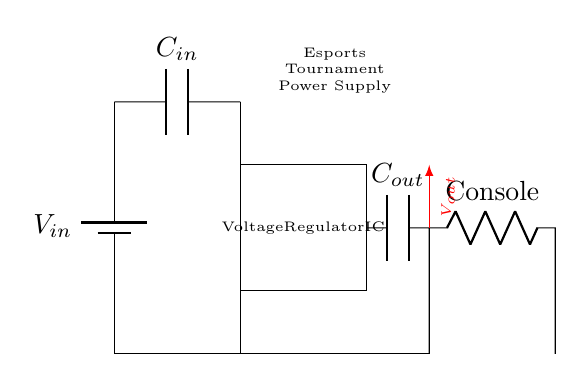What is the type of the power source in this circuit? The power source in the circuit is represented as a battery, indicated by the label "V_in". A battery is a common source of voltage in electronic circuits.
Answer: Battery What is the purpose of the capacitor labeled "C_out"? The capacitor "C_out" filters the output voltage, smoothing it to provide stable power to the connected load, which in this case is a gaming console.
Answer: Smoothing output Which component regulates the voltage in this circuit? The component that regulates the voltage is the Voltage Regulator IC, explicitly labeled in the diagram. This IC manages the output voltage level to maintain a consistent supply.
Answer: Voltage Regulator IC What is the load connected in this circuit? The load in this circuit is a console, as indicated by the label "Console". It draws the regulated voltage supplied by the circuit to operate during the tournament.
Answer: Console Which capacitor is responsible for input smoothing? The capacitor responsible for input smoothing is "C_in", which is connected to the input voltage source, filtering any fluctuations before they reach the regulator.
Answer: C_in How is the ground referenced in this circuit? The ground reference is indicated by the lines connecting to the bottom of the circuit, showing that several components return to a common ground point for a stable reference.
Answer: Common ground What role does the voltage labeled "V_out" play in the circuit? The voltage labeled "V_out" represents the regulated output voltage provided to the connected load (the console), ensuring it receives the proper voltage level necessary for operation.
Answer: Regulated output 